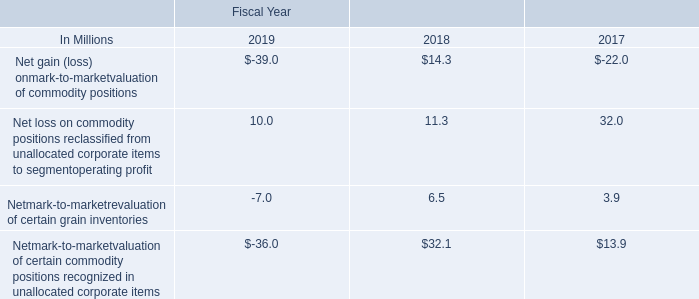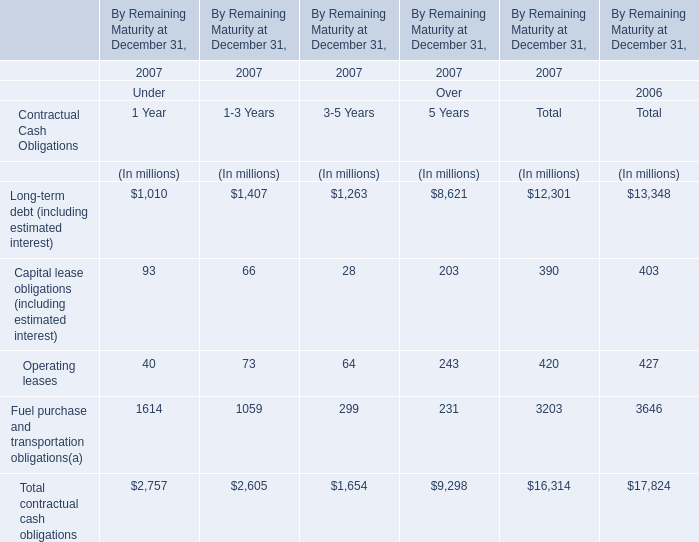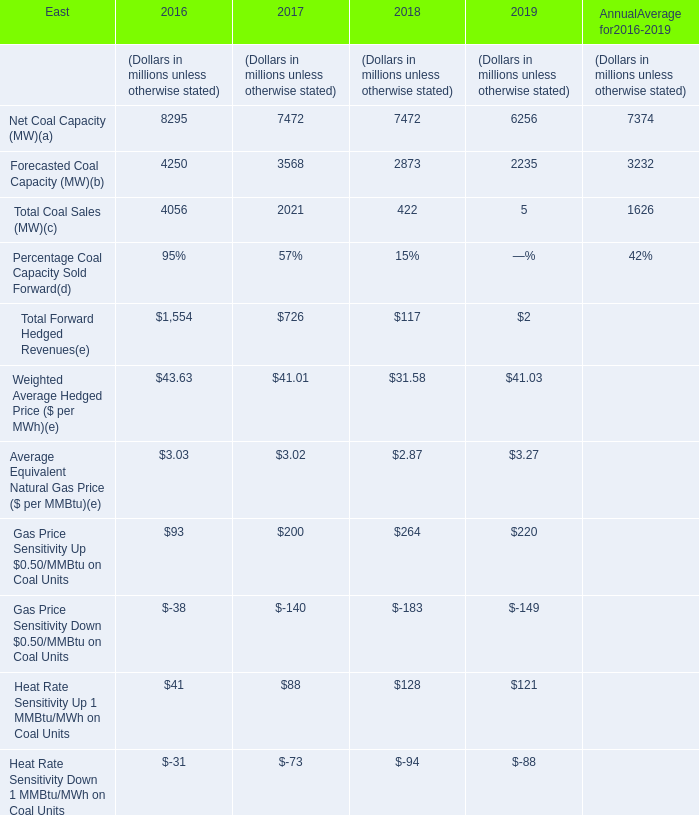What is the sum of the Total Coal Sales in the years where Forecasted Coal Capacity is greater than 3500? (in million) 
Computations: (4056 + 2021)
Answer: 6077.0. 